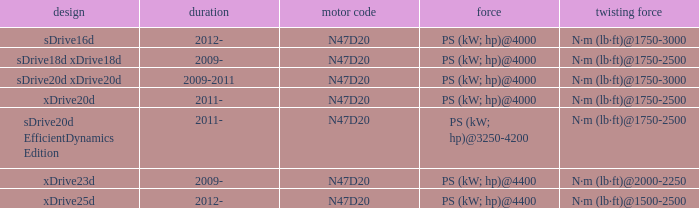What years did the sdrive16d model have a Torque of n·m (lb·ft)@1750-3000? 2012-. Could you parse the entire table? {'header': ['design', 'duration', 'motor code', 'force', 'twisting force'], 'rows': [['sDrive16d', '2012-', 'N47D20', 'PS (kW; hp)@4000', 'N·m (lb·ft)@1750-3000'], ['sDrive18d xDrive18d', '2009-', 'N47D20', 'PS (kW; hp)@4000', 'N·m (lb·ft)@1750-2500'], ['sDrive20d xDrive20d', '2009-2011', 'N47D20', 'PS (kW; hp)@4000', 'N·m (lb·ft)@1750-3000'], ['xDrive20d', '2011-', 'N47D20', 'PS (kW; hp)@4000', 'N·m (lb·ft)@1750-2500'], ['sDrive20d EfficientDynamics Edition', '2011-', 'N47D20', 'PS (kW; hp)@3250-4200', 'N·m (lb·ft)@1750-2500'], ['xDrive23d', '2009-', 'N47D20', 'PS (kW; hp)@4400', 'N·m (lb·ft)@2000-2250'], ['xDrive25d', '2012-', 'N47D20', 'PS (kW; hp)@4400', 'N·m (lb·ft)@1500-2500']]} 